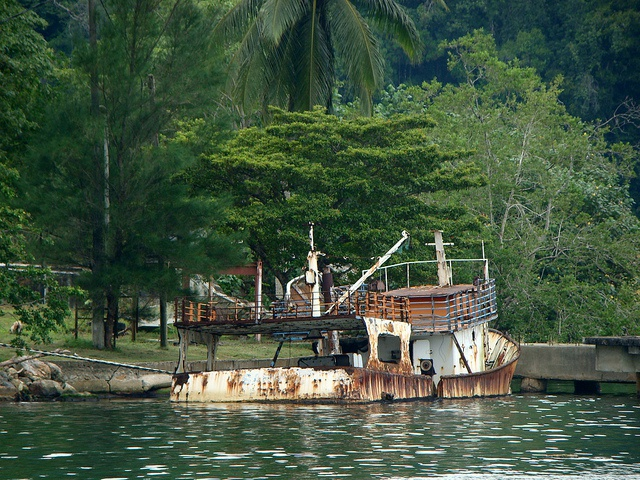Describe the objects in this image and their specific colors. I can see a boat in darkgreen, black, gray, ivory, and darkgray tones in this image. 